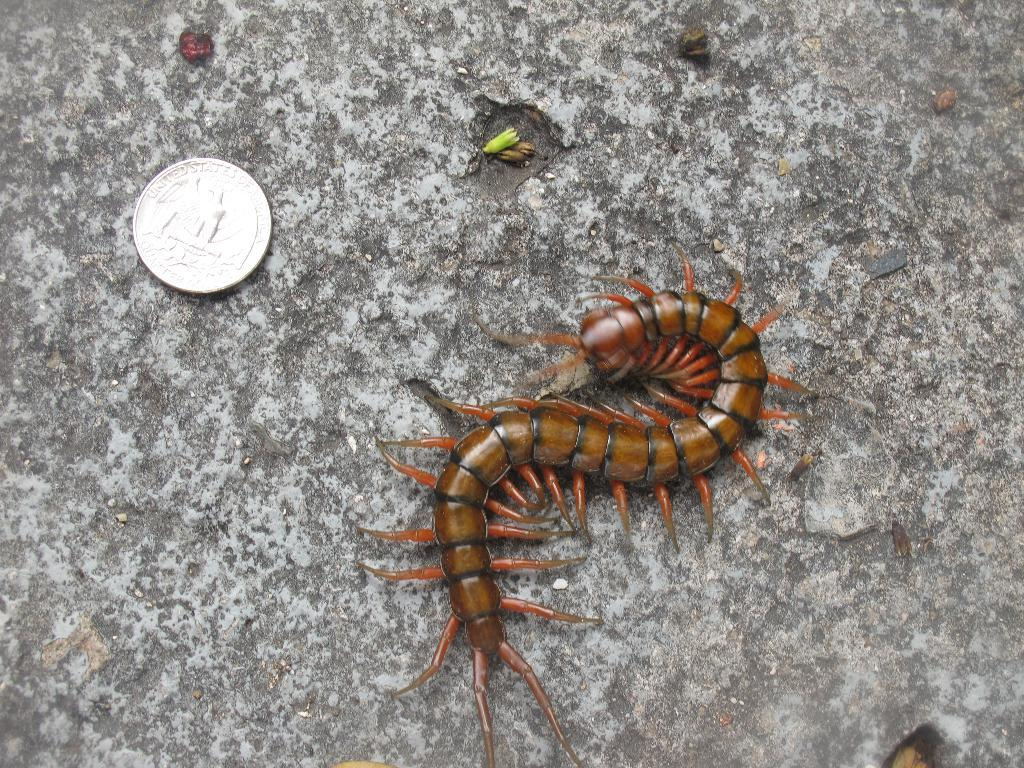What is one of the objects in the image? There is a coin in the image. What other object can be seen in the image? There is a centipede in the image. Where are these objects located? Both objects are on a surface. What type of wool is being used to make a lamp in the image? There is no wool, lamp, or plough present in the image. 